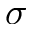<formula> <loc_0><loc_0><loc_500><loc_500>\sigma</formula> 